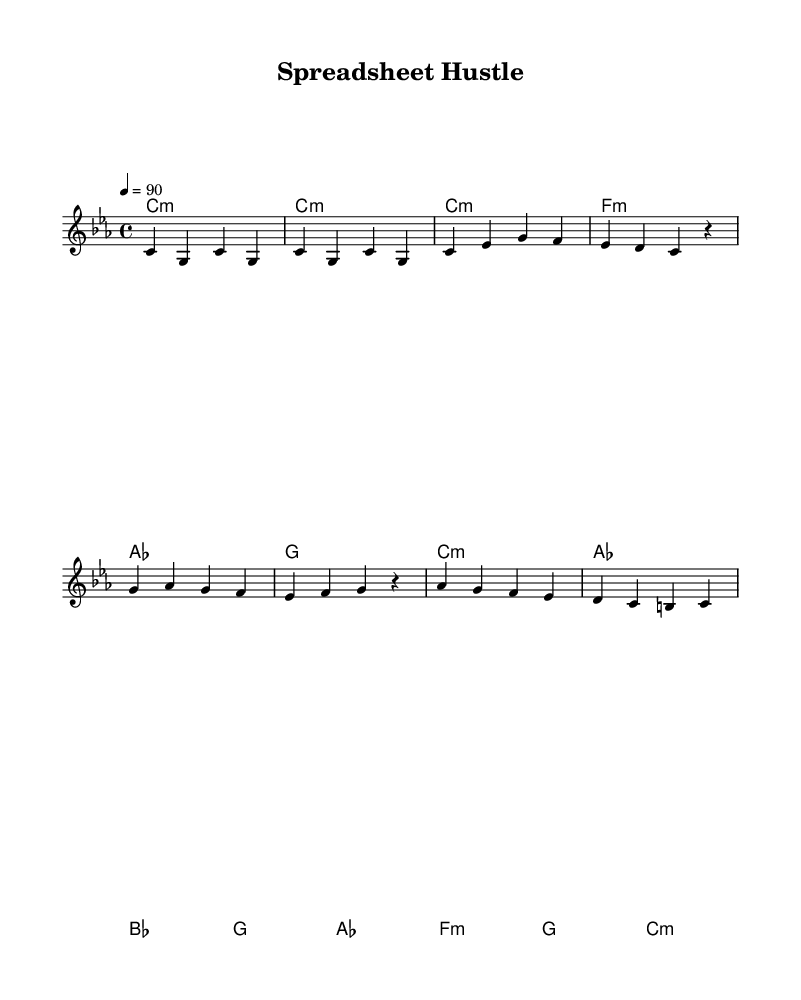What is the key signature of this music? The key signature is indicated at the beginning of the sheet music, and it shows C minor, which has three flats (B, E, and A).
Answer: C minor What is the time signature of this music? The time signature appears just after the key signature and indicates that there are 4 beats per measure, represented as 4/4.
Answer: 4/4 What is the tempo marking for this piece? The tempo is marked at the beginning of the sheet music with the note "4 = 90," meaning there are 90 beats per minute.
Answer: 90 How many distinct sections does the music structure contain? Each distinct section is separated clearly with labels in the music; we see an Intro, Verse, Chorus, and Bridge, totaling four sections.
Answer: Four Which chord is associated with the Chorus section? The Chorus section in the harmonies starts with the chord C minor, followed by A flat major and B flat major, concluding with G major. The first chord listed is what we are interested in.
Answer: C minor What is the last chord in the piece? In the Bridge section, the last chord is noted as C minor, which is the final chord that resolves the piece.
Answer: C minor Which chord appears in the Verse section? In the Verse section, the chords listed are C minor, F minor, A flat major, and G major, with C minor appearing first.
Answer: C minor 